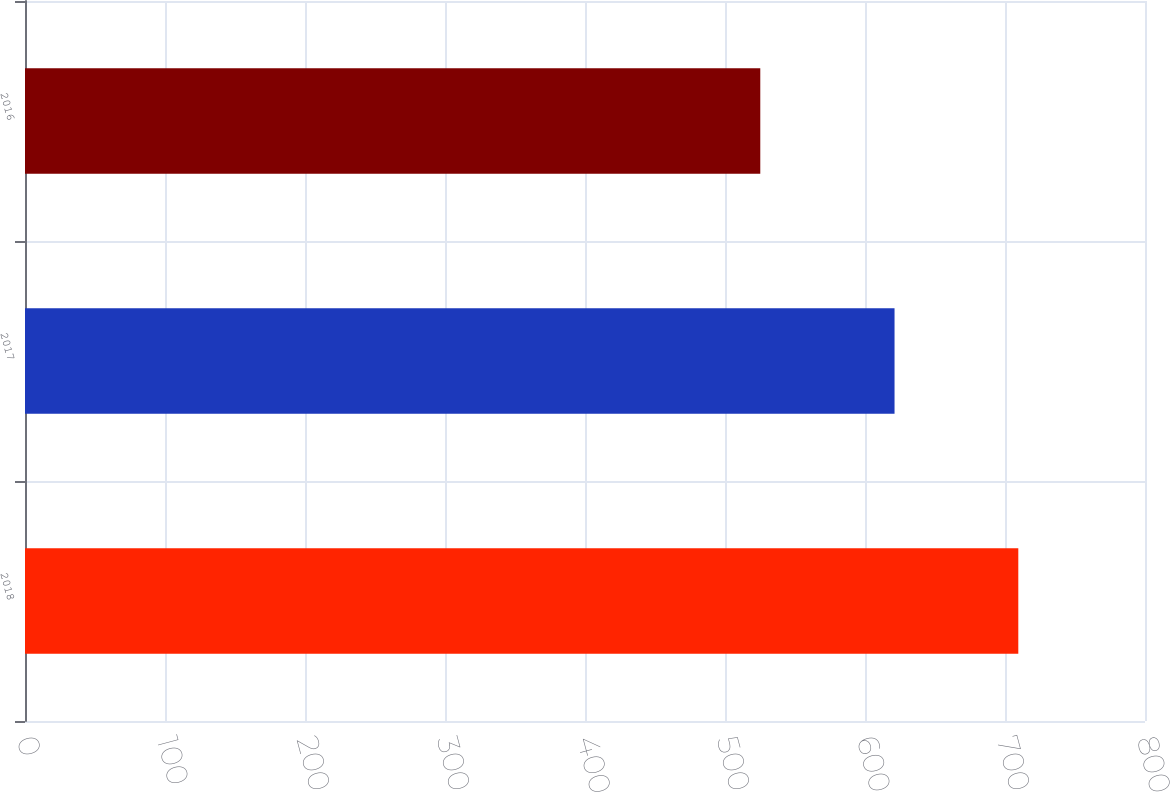<chart> <loc_0><loc_0><loc_500><loc_500><bar_chart><fcel>2018<fcel>2017<fcel>2016<nl><fcel>709.5<fcel>621.1<fcel>525.2<nl></chart> 